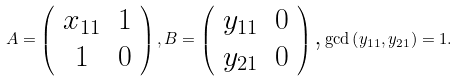<formula> <loc_0><loc_0><loc_500><loc_500>A = \left ( \begin{array} { c c } x _ { 1 1 } & 1 \\ 1 & 0 \end{array} \right ) , B = \left ( \begin{array} { c c } y _ { 1 1 } & 0 \\ y _ { 2 1 } & 0 \end{array} \right ) \text {,} \gcd \left ( y _ { 1 1 } , y _ { 2 1 } \right ) = 1 .</formula> 